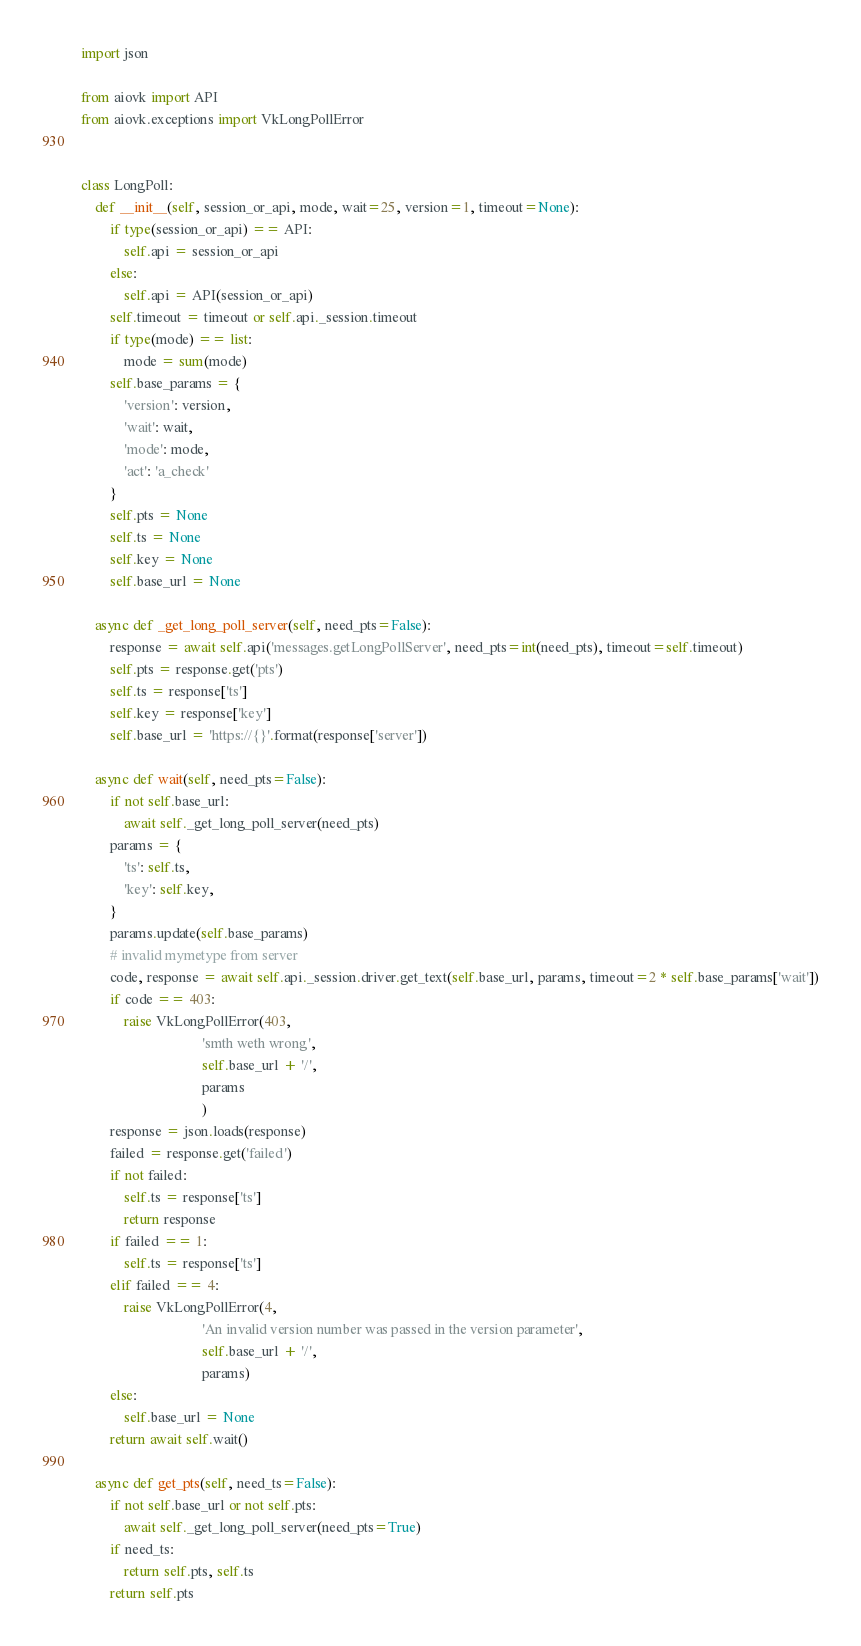Convert code to text. <code><loc_0><loc_0><loc_500><loc_500><_Python_>import json

from aiovk import API
from aiovk.exceptions import VkLongPollError


class LongPoll:
    def __init__(self, session_or_api, mode, wait=25, version=1, timeout=None):
        if type(session_or_api) == API:
            self.api = session_or_api
        else:
            self.api = API(session_or_api)
        self.timeout = timeout or self.api._session.timeout
        if type(mode) == list:
            mode = sum(mode)
        self.base_params = {
            'version': version,
            'wait': wait,
            'mode': mode,
            'act': 'a_check'
        }
        self.pts = None
        self.ts = None
        self.key = None
        self.base_url = None

    async def _get_long_poll_server(self, need_pts=False):
        response = await self.api('messages.getLongPollServer', need_pts=int(need_pts), timeout=self.timeout)
        self.pts = response.get('pts')
        self.ts = response['ts']
        self.key = response['key']
        self.base_url = 'https://{}'.format(response['server'])

    async def wait(self, need_pts=False):
        if not self.base_url:
            await self._get_long_poll_server(need_pts)
        params = {
            'ts': self.ts,
            'key': self.key,
        }
        params.update(self.base_params)
        # invalid mymetype from server
        code, response = await self.api._session.driver.get_text(self.base_url, params, timeout=2 * self.base_params['wait'])
        if code == 403:
            raise VkLongPollError(403,
                                  'smth weth wrong',
                                  self.base_url + '/',
                                  params
                                  )
        response = json.loads(response)
        failed = response.get('failed')
        if not failed:
            self.ts = response['ts']
            return response
        if failed == 1:
            self.ts = response['ts']
        elif failed == 4:
            raise VkLongPollError(4,
                                  'An invalid version number was passed in the version parameter',
                                  self.base_url + '/',
                                  params)
        else:
            self.base_url = None
        return await self.wait()

    async def get_pts(self, need_ts=False):
        if not self.base_url or not self.pts:
            await self._get_long_poll_server(need_pts=True)
        if need_ts:
            return self.pts, self.ts
        return self.pts
</code> 